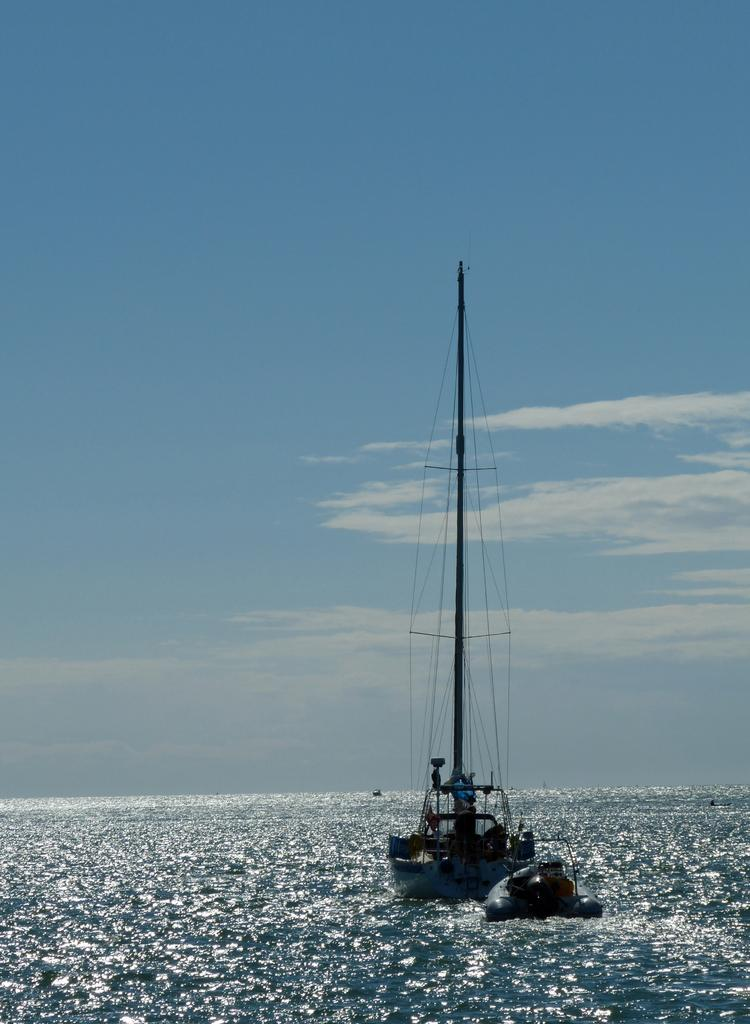What is the main subject of the image? There is a ship in the image. Where is the ship located? The ship is on a river. What can be seen in the background of the image? There is a sky visible in the background of the image. What type of jeans is the stone wearing in the image? There is no stone or jeans present in the image; it features a ship on a river with a visible sky in the background. 